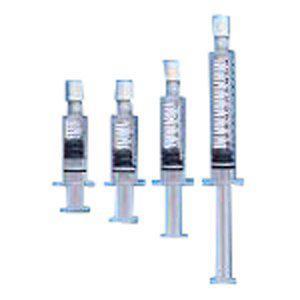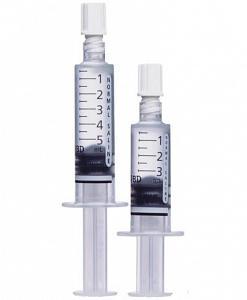The first image is the image on the left, the second image is the image on the right. For the images shown, is this caption "The right image shows a single syringe." true? Answer yes or no. No. 